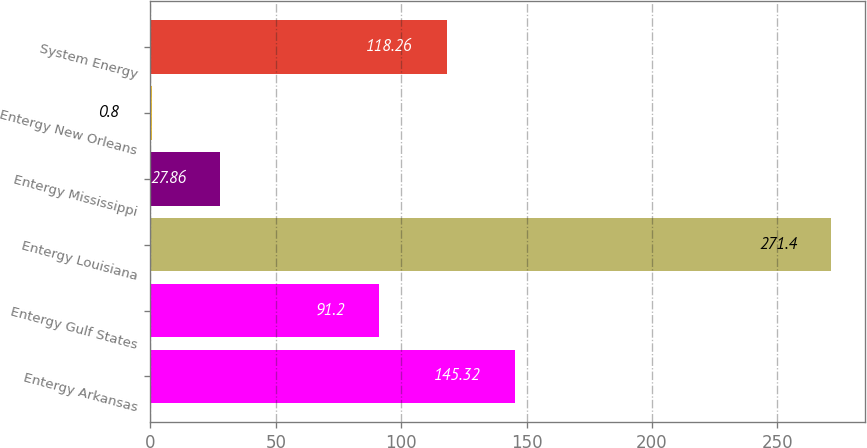Convert chart. <chart><loc_0><loc_0><loc_500><loc_500><bar_chart><fcel>Entergy Arkansas<fcel>Entergy Gulf States<fcel>Entergy Louisiana<fcel>Entergy Mississippi<fcel>Entergy New Orleans<fcel>System Energy<nl><fcel>145.32<fcel>91.2<fcel>271.4<fcel>27.86<fcel>0.8<fcel>118.26<nl></chart> 